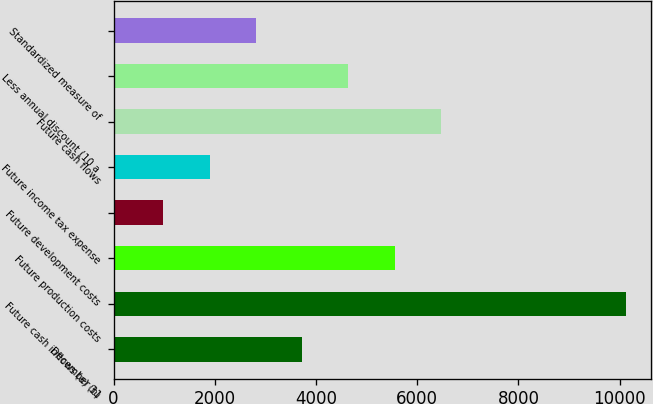Convert chart. <chart><loc_0><loc_0><loc_500><loc_500><bar_chart><fcel>December 31<fcel>Future cash inflows (a) (b)<fcel>Future production costs<fcel>Future development costs<fcel>Future income tax expense<fcel>Future cash flows<fcel>Less annual discount (10 a<fcel>Standardized measure of<nl><fcel>3726.2<fcel>10120<fcel>5553<fcel>986<fcel>1899.4<fcel>6466.4<fcel>4639.6<fcel>2812.8<nl></chart> 